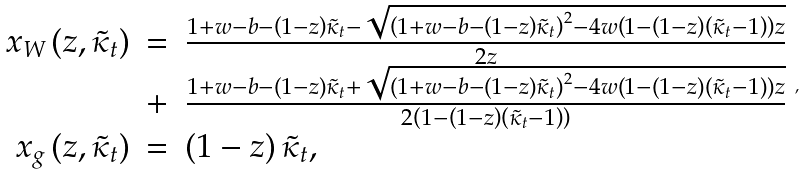Convert formula to latex. <formula><loc_0><loc_0><loc_500><loc_500>\begin{array} { r c l } x _ { W } \left ( z , \tilde { \kappa } _ { t } \right ) & = & \frac { 1 + w - b - \left ( 1 - z \right ) \tilde { \kappa } _ { t } - \sqrt { \left ( 1 + w - b - \left ( 1 - z \right ) \tilde { \kappa } _ { t } \right ) ^ { 2 } - 4 w \left ( 1 - \left ( 1 - z \right ) \left ( \tilde { \kappa } _ { t } - 1 \right ) \right ) z } } { 2 z } \\ & + & \frac { 1 + w - b - \left ( 1 - z \right ) \tilde { \kappa } _ { t } + \sqrt { \left ( 1 + w - b - \left ( 1 - z \right ) \tilde { \kappa } _ { t } \right ) ^ { 2 } - 4 w \left ( 1 - \left ( 1 - z \right ) \left ( \tilde { \kappa } _ { t } - 1 \right ) \right ) z } } { 2 \left ( 1 - \left ( 1 - z \right ) \left ( \tilde { \kappa } _ { t } - 1 \right ) \right ) } \\ x _ { g } \left ( z , \tilde { \kappa } _ { t } \right ) & = & \left ( 1 - z \right ) \tilde { \kappa } _ { t } , \end{array} ,</formula> 